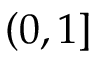<formula> <loc_0><loc_0><loc_500><loc_500>\left ( 0 , 1 \right ]</formula> 